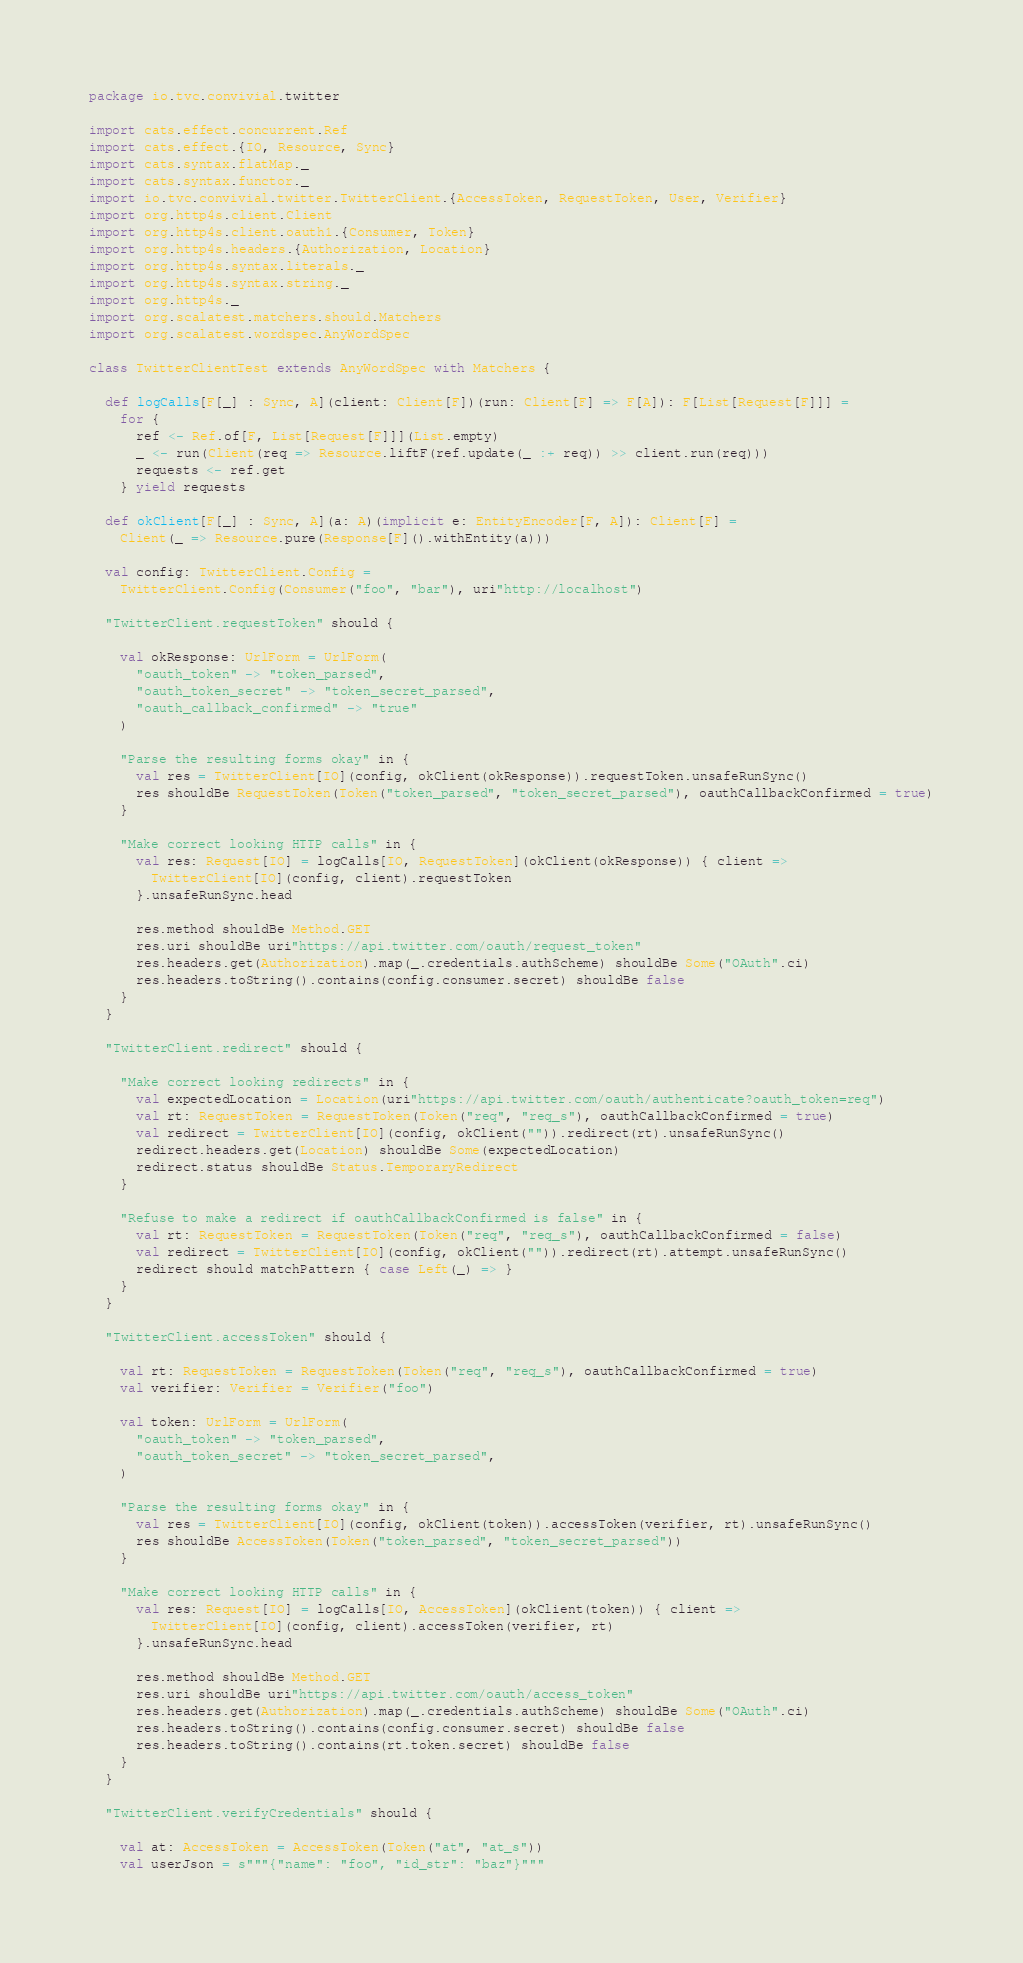<code> <loc_0><loc_0><loc_500><loc_500><_Scala_>package io.tvc.convivial.twitter

import cats.effect.concurrent.Ref
import cats.effect.{IO, Resource, Sync}
import cats.syntax.flatMap._
import cats.syntax.functor._
import io.tvc.convivial.twitter.TwitterClient.{AccessToken, RequestToken, User, Verifier}
import org.http4s.client.Client
import org.http4s.client.oauth1.{Consumer, Token}
import org.http4s.headers.{Authorization, Location}
import org.http4s.syntax.literals._
import org.http4s.syntax.string._
import org.http4s._
import org.scalatest.matchers.should.Matchers
import org.scalatest.wordspec.AnyWordSpec

class TwitterClientTest extends AnyWordSpec with Matchers {

  def logCalls[F[_] : Sync, A](client: Client[F])(run: Client[F] => F[A]): F[List[Request[F]]] =
    for {
      ref <- Ref.of[F, List[Request[F]]](List.empty)
      _ <- run(Client(req => Resource.liftF(ref.update(_ :+ req)) >> client.run(req)))
      requests <- ref.get
    } yield requests

  def okClient[F[_] : Sync, A](a: A)(implicit e: EntityEncoder[F, A]): Client[F] =
    Client(_ => Resource.pure(Response[F]().withEntity(a)))

  val config: TwitterClient.Config =
    TwitterClient.Config(Consumer("foo", "bar"), uri"http://localhost")

  "TwitterClient.requestToken" should {

    val okResponse: UrlForm = UrlForm(
      "oauth_token" -> "token_parsed",
      "oauth_token_secret" -> "token_secret_parsed",
      "oauth_callback_confirmed" -> "true"
    )

    "Parse the resulting forms okay" in {
      val res = TwitterClient[IO](config, okClient(okResponse)).requestToken.unsafeRunSync()
      res shouldBe RequestToken(Token("token_parsed", "token_secret_parsed"), oauthCallbackConfirmed = true)
    }

    "Make correct looking HTTP calls" in {
      val res: Request[IO] = logCalls[IO, RequestToken](okClient(okResponse)) { client =>
        TwitterClient[IO](config, client).requestToken
      }.unsafeRunSync.head

      res.method shouldBe Method.GET
      res.uri shouldBe uri"https://api.twitter.com/oauth/request_token"
      res.headers.get(Authorization).map(_.credentials.authScheme) shouldBe Some("OAuth".ci)
      res.headers.toString().contains(config.consumer.secret) shouldBe false
    }
  }

  "TwitterClient.redirect" should {

    "Make correct looking redirects" in {
      val expectedLocation = Location(uri"https://api.twitter.com/oauth/authenticate?oauth_token=req")
      val rt: RequestToken = RequestToken(Token("req", "req_s"), oauthCallbackConfirmed = true)
      val redirect = TwitterClient[IO](config, okClient("")).redirect(rt).unsafeRunSync()
      redirect.headers.get(Location) shouldBe Some(expectedLocation)
      redirect.status shouldBe Status.TemporaryRedirect
    }

    "Refuse to make a redirect if oauthCallbackConfirmed is false" in {
      val rt: RequestToken = RequestToken(Token("req", "req_s"), oauthCallbackConfirmed = false)
      val redirect = TwitterClient[IO](config, okClient("")).redirect(rt).attempt.unsafeRunSync()
      redirect should matchPattern { case Left(_) => }
    }
  }

  "TwitterClient.accessToken" should {

    val rt: RequestToken = RequestToken(Token("req", "req_s"), oauthCallbackConfirmed = true)
    val verifier: Verifier = Verifier("foo")

    val token: UrlForm = UrlForm(
      "oauth_token" -> "token_parsed",
      "oauth_token_secret" -> "token_secret_parsed",
    )

    "Parse the resulting forms okay" in {
      val res = TwitterClient[IO](config, okClient(token)).accessToken(verifier, rt).unsafeRunSync()
      res shouldBe AccessToken(Token("token_parsed", "token_secret_parsed"))
    }

    "Make correct looking HTTP calls" in {
      val res: Request[IO] = logCalls[IO, AccessToken](okClient(token)) { client =>
        TwitterClient[IO](config, client).accessToken(verifier, rt)
      }.unsafeRunSync.head

      res.method shouldBe Method.GET
      res.uri shouldBe uri"https://api.twitter.com/oauth/access_token"
      res.headers.get(Authorization).map(_.credentials.authScheme) shouldBe Some("OAuth".ci)
      res.headers.toString().contains(config.consumer.secret) shouldBe false
      res.headers.toString().contains(rt.token.secret) shouldBe false
    }
  }

  "TwitterClient.verifyCredentials" should {

    val at: AccessToken = AccessToken(Token("at", "at_s"))
    val userJson = s"""{"name": "foo", "id_str": "baz"}"""</code> 